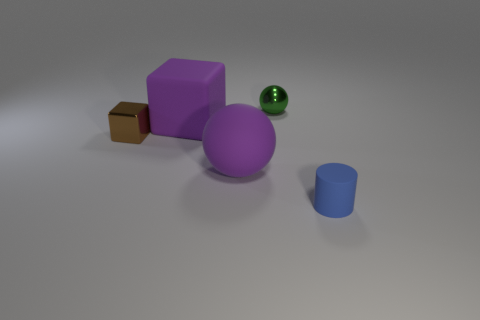Add 1 large matte things. How many objects exist? 6 Subtract all spheres. How many objects are left? 3 Subtract all tiny gray shiny things. Subtract all small cubes. How many objects are left? 4 Add 5 purple rubber cubes. How many purple rubber cubes are left? 6 Add 4 green balls. How many green balls exist? 5 Subtract 1 brown cubes. How many objects are left? 4 